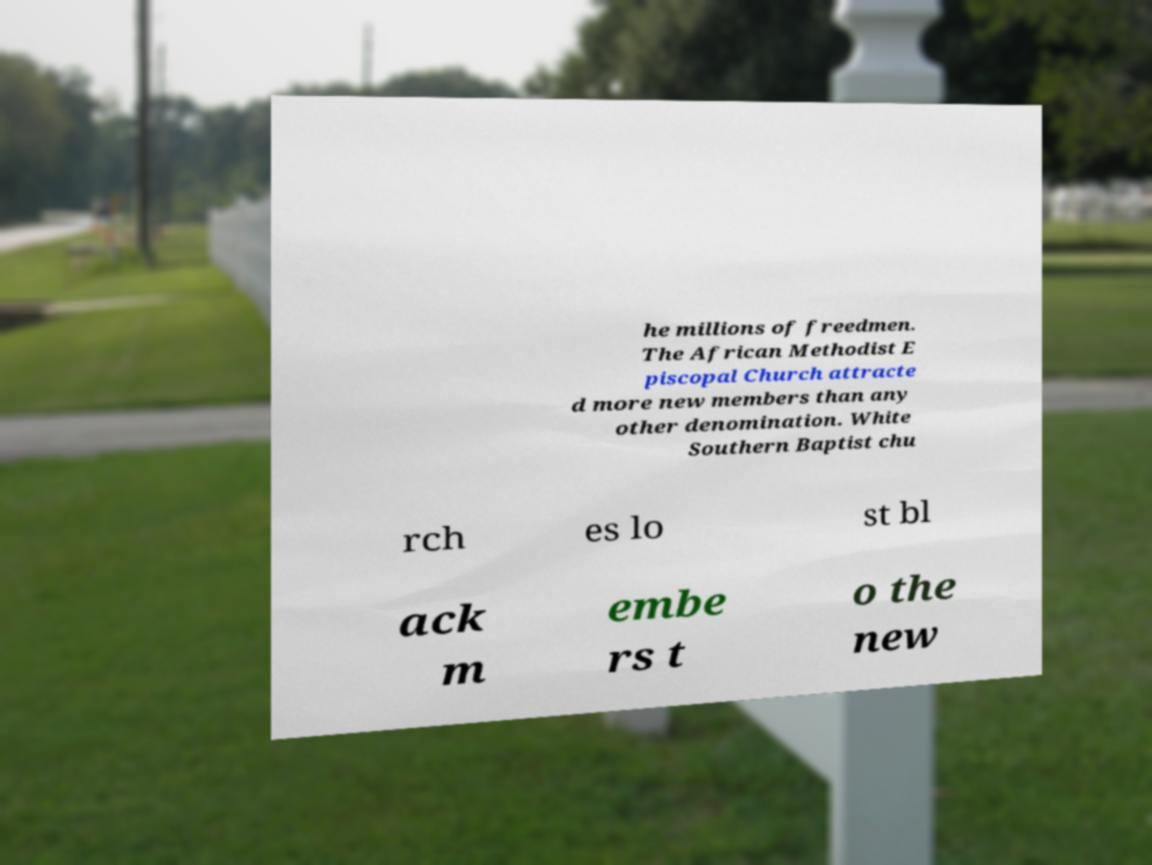Could you assist in decoding the text presented in this image and type it out clearly? he millions of freedmen. The African Methodist E piscopal Church attracte d more new members than any other denomination. White Southern Baptist chu rch es lo st bl ack m embe rs t o the new 